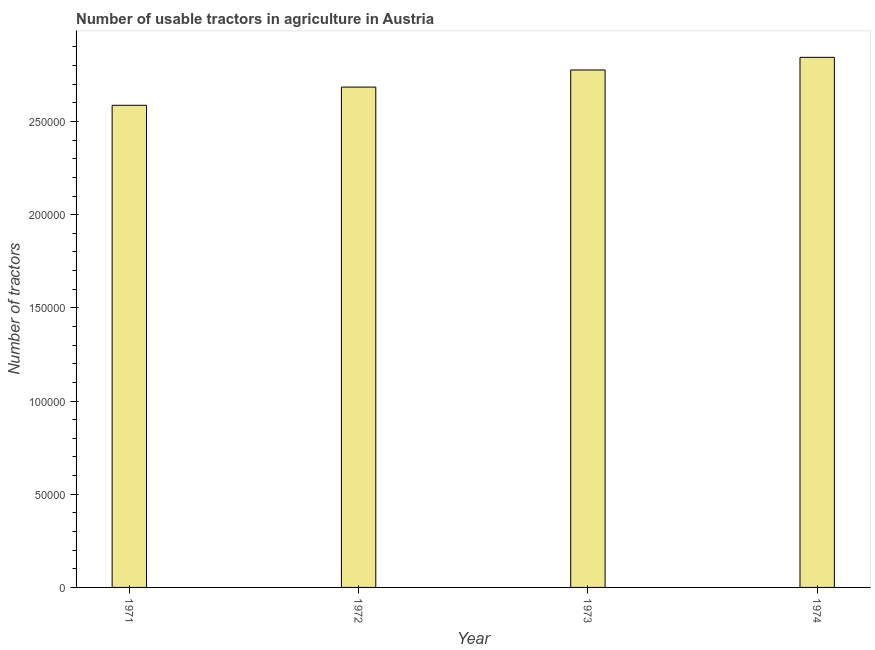Does the graph contain any zero values?
Ensure brevity in your answer.  No. What is the title of the graph?
Your answer should be compact. Number of usable tractors in agriculture in Austria. What is the label or title of the Y-axis?
Give a very brief answer. Number of tractors. What is the number of tractors in 1974?
Provide a succinct answer. 2.84e+05. Across all years, what is the maximum number of tractors?
Provide a short and direct response. 2.84e+05. Across all years, what is the minimum number of tractors?
Your answer should be very brief. 2.59e+05. In which year was the number of tractors maximum?
Provide a succinct answer. 1974. In which year was the number of tractors minimum?
Offer a terse response. 1971. What is the sum of the number of tractors?
Your answer should be compact. 1.09e+06. What is the difference between the number of tractors in 1971 and 1974?
Make the answer very short. -2.57e+04. What is the average number of tractors per year?
Your answer should be very brief. 2.72e+05. What is the median number of tractors?
Ensure brevity in your answer.  2.73e+05. In how many years, is the number of tractors greater than 190000 ?
Your answer should be very brief. 4. Do a majority of the years between 1972 and 1971 (inclusive) have number of tractors greater than 120000 ?
Make the answer very short. No. What is the ratio of the number of tractors in 1971 to that in 1973?
Offer a terse response. 0.93. Is the number of tractors in 1972 less than that in 1973?
Your response must be concise. Yes. Is the difference between the number of tractors in 1971 and 1972 greater than the difference between any two years?
Make the answer very short. No. What is the difference between the highest and the second highest number of tractors?
Your answer should be compact. 6783. Is the sum of the number of tractors in 1973 and 1974 greater than the maximum number of tractors across all years?
Your answer should be very brief. Yes. What is the difference between the highest and the lowest number of tractors?
Your answer should be compact. 2.57e+04. How many years are there in the graph?
Provide a succinct answer. 4. What is the difference between two consecutive major ticks on the Y-axis?
Your answer should be very brief. 5.00e+04. What is the Number of tractors in 1971?
Provide a short and direct response. 2.59e+05. What is the Number of tractors in 1972?
Ensure brevity in your answer.  2.68e+05. What is the Number of tractors of 1973?
Offer a very short reply. 2.78e+05. What is the Number of tractors of 1974?
Ensure brevity in your answer.  2.84e+05. What is the difference between the Number of tractors in 1971 and 1972?
Provide a succinct answer. -9769. What is the difference between the Number of tractors in 1971 and 1973?
Provide a succinct answer. -1.89e+04. What is the difference between the Number of tractors in 1971 and 1974?
Your response must be concise. -2.57e+04. What is the difference between the Number of tractors in 1972 and 1973?
Your answer should be compact. -9178. What is the difference between the Number of tractors in 1972 and 1974?
Offer a terse response. -1.60e+04. What is the difference between the Number of tractors in 1973 and 1974?
Your answer should be very brief. -6783. What is the ratio of the Number of tractors in 1971 to that in 1973?
Your answer should be compact. 0.93. What is the ratio of the Number of tractors in 1971 to that in 1974?
Offer a terse response. 0.91. What is the ratio of the Number of tractors in 1972 to that in 1974?
Your answer should be very brief. 0.94. What is the ratio of the Number of tractors in 1973 to that in 1974?
Offer a terse response. 0.98. 